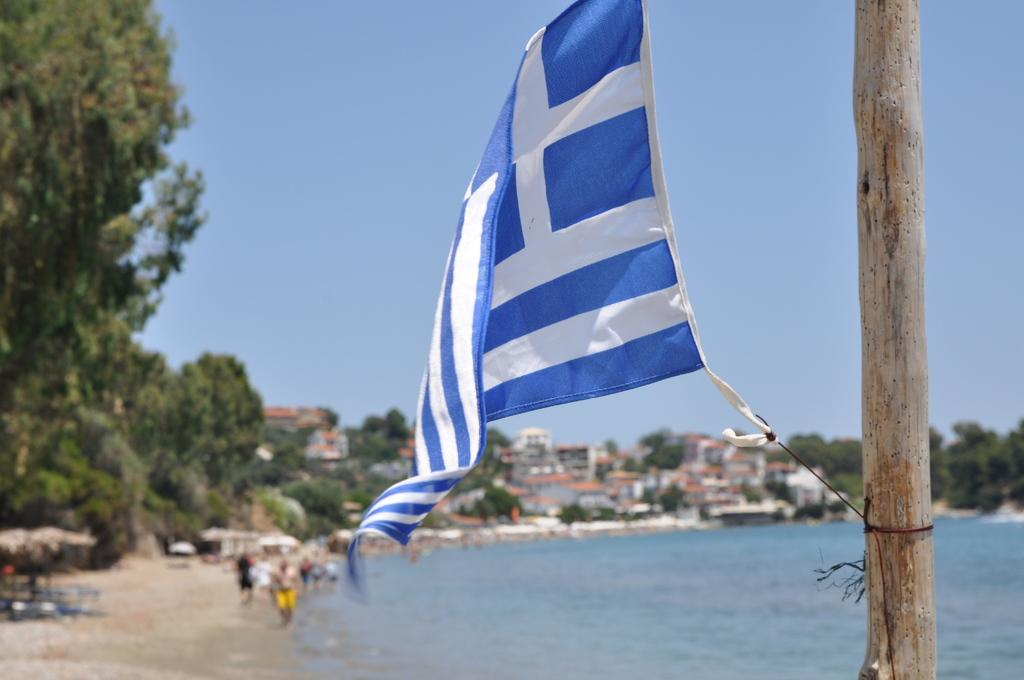What is located on the right side of the image? There is a pole with a flag on the right side of the image. What can be seen in the background of the image? The sky, trees, buildings, water, and people are visible in the background of the image. Can you describe the natural elements in the background of the image? The natural elements in the background include trees and water. How many types of structures are visible in the background of the image? There are two types of structures visible in the background: buildings and a pole with a flag. What month is it in the image? The month cannot be determined from the image, as there is no information about the time of year. What type of observation can be made from the building in the image? There is no specific observation mentioned in the image, and the building is not the main focus of the image. 